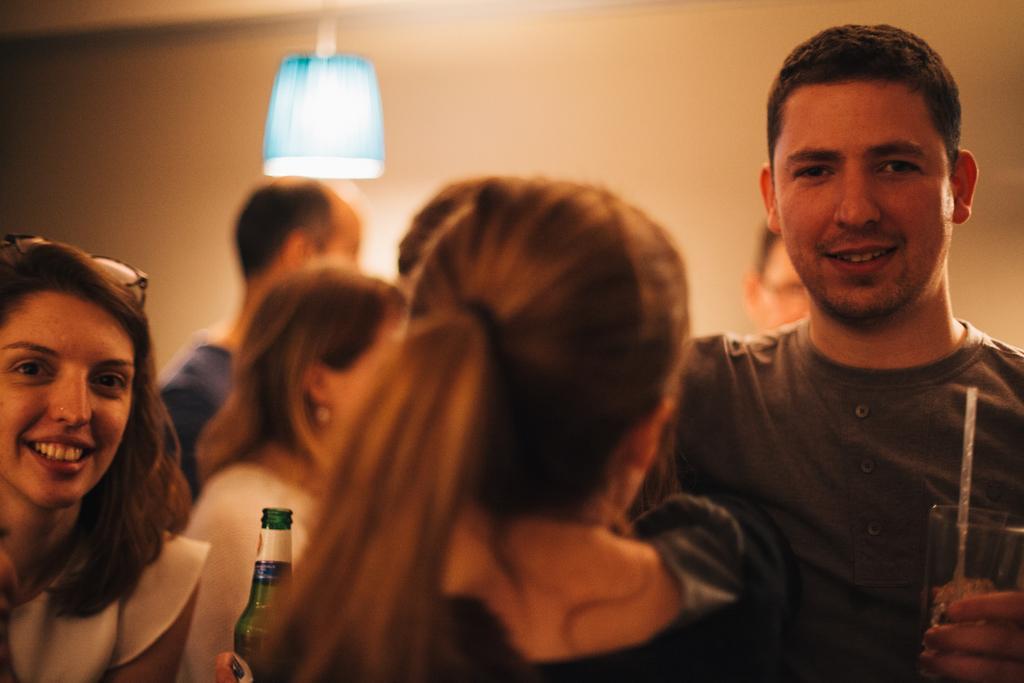Describe this image in one or two sentences. As we can see in the image there is a wall, lamp, few people here and there and there is a bottle over here. 